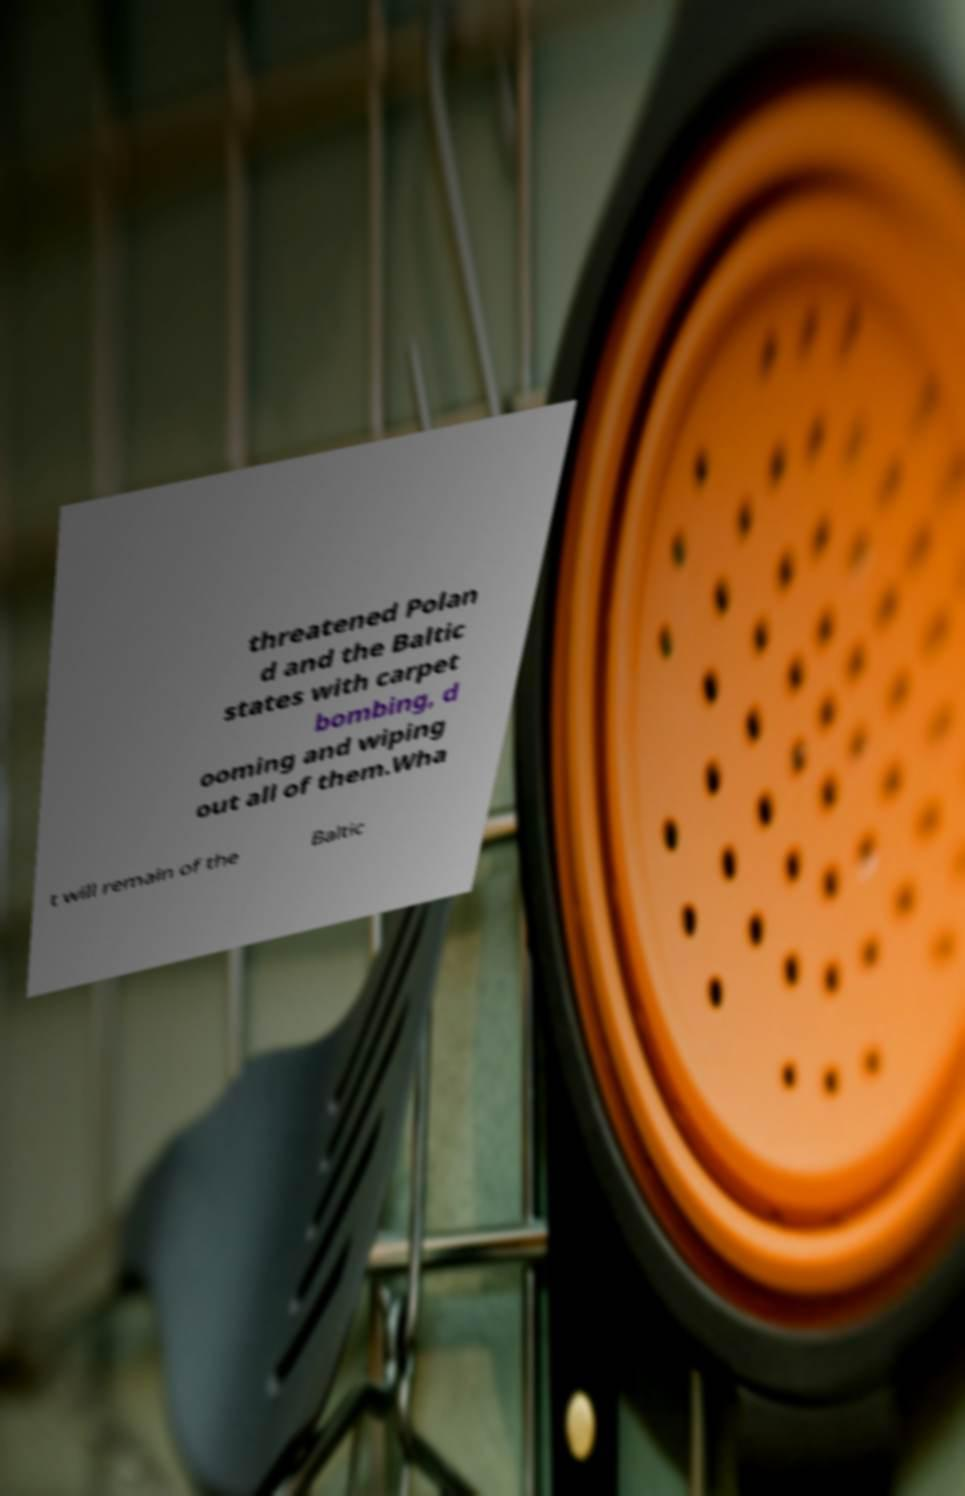Can you accurately transcribe the text from the provided image for me? threatened Polan d and the Baltic states with carpet bombing, d ooming and wiping out all of them.Wha t will remain of the Baltic 